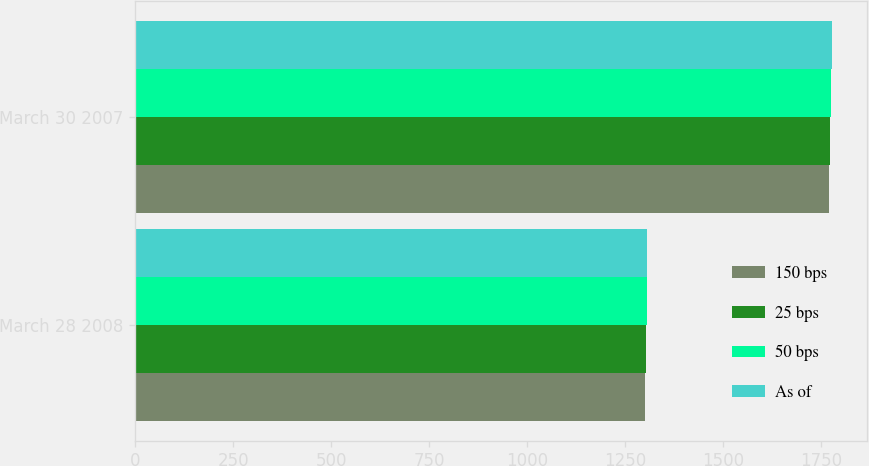<chart> <loc_0><loc_0><loc_500><loc_500><stacked_bar_chart><ecel><fcel>March 28 2008<fcel>March 30 2007<nl><fcel>150 bps<fcel>1301<fcel>1770<nl><fcel>25 bps<fcel>1302<fcel>1772<nl><fcel>50 bps<fcel>1304<fcel>1775<nl><fcel>As of<fcel>1305<fcel>1778<nl></chart> 